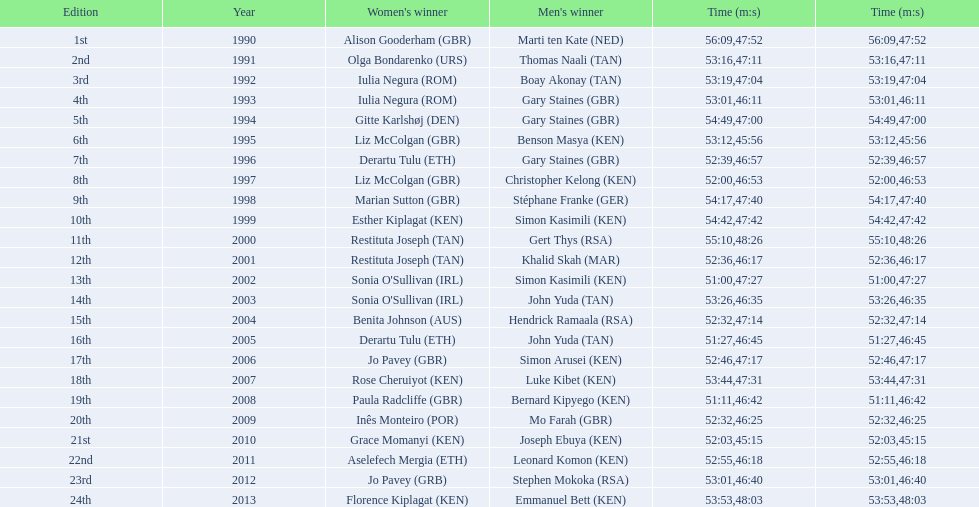Could you parse the entire table? {'header': ['Edition', 'Year', "Women's winner", "Men's winner", 'Time (m:s)', 'Time (m:s)'], 'rows': [['1st', '1990', 'Alison Gooderham\xa0(GBR)', 'Marti ten Kate\xa0(NED)', '56:09', '47:52'], ['2nd', '1991', 'Olga Bondarenko\xa0(URS)', 'Thomas Naali\xa0(TAN)', '53:16', '47:11'], ['3rd', '1992', 'Iulia Negura\xa0(ROM)', 'Boay Akonay\xa0(TAN)', '53:19', '47:04'], ['4th', '1993', 'Iulia Negura\xa0(ROM)', 'Gary Staines\xa0(GBR)', '53:01', '46:11'], ['5th', '1994', 'Gitte Karlshøj\xa0(DEN)', 'Gary Staines\xa0(GBR)', '54:49', '47:00'], ['6th', '1995', 'Liz McColgan\xa0(GBR)', 'Benson Masya\xa0(KEN)', '53:12', '45:56'], ['7th', '1996', 'Derartu Tulu\xa0(ETH)', 'Gary Staines\xa0(GBR)', '52:39', '46:57'], ['8th', '1997', 'Liz McColgan\xa0(GBR)', 'Christopher Kelong\xa0(KEN)', '52:00', '46:53'], ['9th', '1998', 'Marian Sutton\xa0(GBR)', 'Stéphane Franke\xa0(GER)', '54:17', '47:40'], ['10th', '1999', 'Esther Kiplagat\xa0(KEN)', 'Simon Kasimili\xa0(KEN)', '54:42', '47:42'], ['11th', '2000', 'Restituta Joseph\xa0(TAN)', 'Gert Thys\xa0(RSA)', '55:10', '48:26'], ['12th', '2001', 'Restituta Joseph\xa0(TAN)', 'Khalid Skah\xa0(MAR)', '52:36', '46:17'], ['13th', '2002', "Sonia O'Sullivan\xa0(IRL)", 'Simon Kasimili\xa0(KEN)', '51:00', '47:27'], ['14th', '2003', "Sonia O'Sullivan\xa0(IRL)", 'John Yuda\xa0(TAN)', '53:26', '46:35'], ['15th', '2004', 'Benita Johnson\xa0(AUS)', 'Hendrick Ramaala\xa0(RSA)', '52:32', '47:14'], ['16th', '2005', 'Derartu Tulu\xa0(ETH)', 'John Yuda\xa0(TAN)', '51:27', '46:45'], ['17th', '2006', 'Jo Pavey\xa0(GBR)', 'Simon Arusei\xa0(KEN)', '52:46', '47:17'], ['18th', '2007', 'Rose Cheruiyot\xa0(KEN)', 'Luke Kibet\xa0(KEN)', '53:44', '47:31'], ['19th', '2008', 'Paula Radcliffe\xa0(GBR)', 'Bernard Kipyego\xa0(KEN)', '51:11', '46:42'], ['20th', '2009', 'Inês Monteiro\xa0(POR)', 'Mo Farah\xa0(GBR)', '52:32', '46:25'], ['21st', '2010', 'Grace Momanyi\xa0(KEN)', 'Joseph Ebuya\xa0(KEN)', '52:03', '45:15'], ['22nd', '2011', 'Aselefech Mergia\xa0(ETH)', 'Leonard Komon\xa0(KEN)', '52:55', '46:18'], ['23rd', '2012', 'Jo Pavey\xa0(GRB)', 'Stephen Mokoka\xa0(RSA)', '53:01', '46:40'], ['24th', '2013', 'Florence Kiplagat\xa0(KEN)', 'Emmanuel Bett\xa0(KEN)', '53:53', '48:03']]} Number of men's winners with a finish time under 46:58 12. 